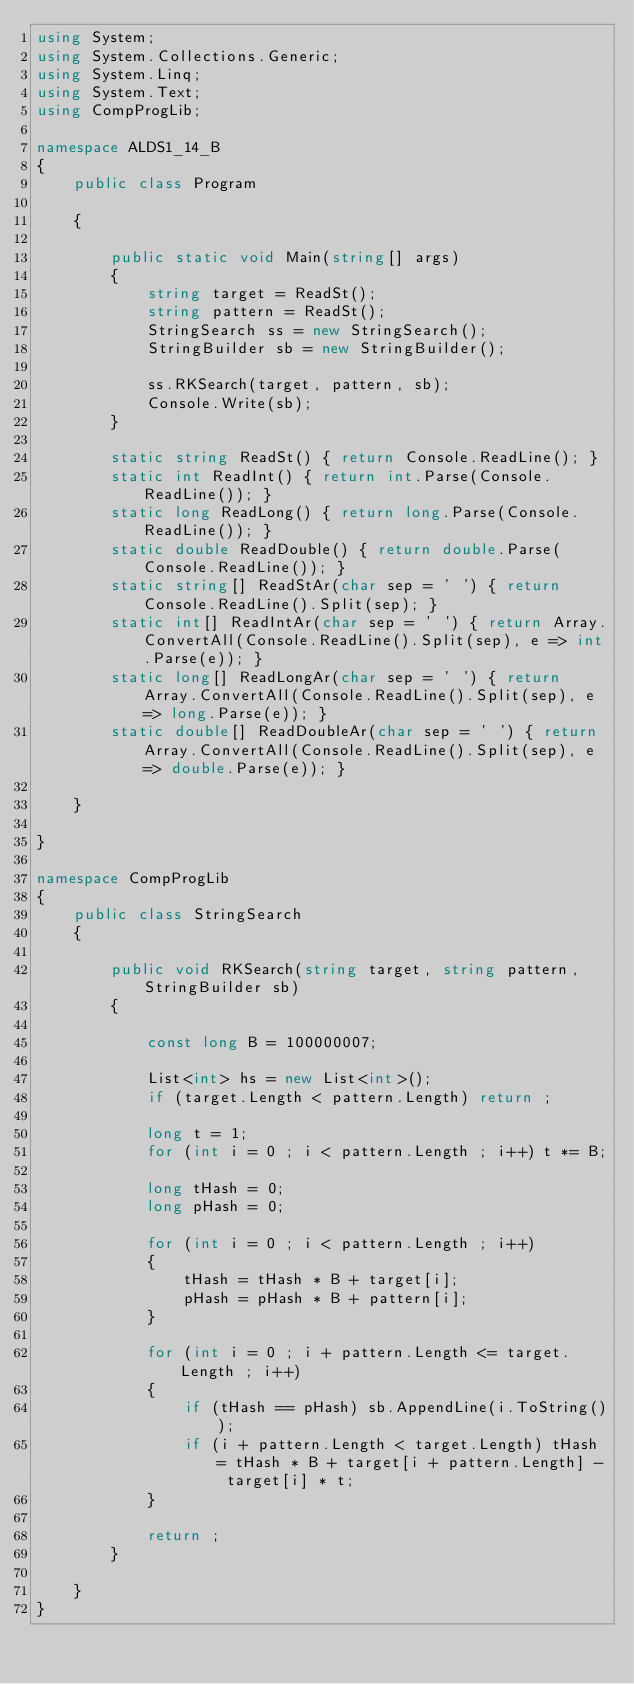<code> <loc_0><loc_0><loc_500><loc_500><_C#_>using System;
using System.Collections.Generic;
using System.Linq;
using System.Text;
using CompProgLib;

namespace ALDS1_14_B
{
    public class Program

    {

        public static void Main(string[] args)
        {
            string target = ReadSt();
            string pattern = ReadSt();
            StringSearch ss = new StringSearch();
            StringBuilder sb = new StringBuilder();

            ss.RKSearch(target, pattern, sb);
            Console.Write(sb);
        }

        static string ReadSt() { return Console.ReadLine(); }
        static int ReadInt() { return int.Parse(Console.ReadLine()); }
        static long ReadLong() { return long.Parse(Console.ReadLine()); }
        static double ReadDouble() { return double.Parse(Console.ReadLine()); }
        static string[] ReadStAr(char sep = ' ') { return Console.ReadLine().Split(sep); }
        static int[] ReadIntAr(char sep = ' ') { return Array.ConvertAll(Console.ReadLine().Split(sep), e => int.Parse(e)); }
        static long[] ReadLongAr(char sep = ' ') { return Array.ConvertAll(Console.ReadLine().Split(sep), e => long.Parse(e)); }
        static double[] ReadDoubleAr(char sep = ' ') { return Array.ConvertAll(Console.ReadLine().Split(sep), e => double.Parse(e)); }

    }

}

namespace CompProgLib
{
    public class StringSearch
    {

        public void RKSearch(string target, string pattern, StringBuilder sb)
        {

            const long B = 100000007;

            List<int> hs = new List<int>();
            if (target.Length < pattern.Length) return ;

            long t = 1;
            for (int i = 0 ; i < pattern.Length ; i++) t *= B;

            long tHash = 0;
            long pHash = 0;

            for (int i = 0 ; i < pattern.Length ; i++)
            {
                tHash = tHash * B + target[i];
                pHash = pHash * B + pattern[i];
            }

            for (int i = 0 ; i + pattern.Length <= target.Length ; i++)
            {
                if (tHash == pHash) sb.AppendLine(i.ToString());
                if (i + pattern.Length < target.Length) tHash = tHash * B + target[i + pattern.Length] - target[i] * t;
            }

            return ;
        }

    }
}
</code> 